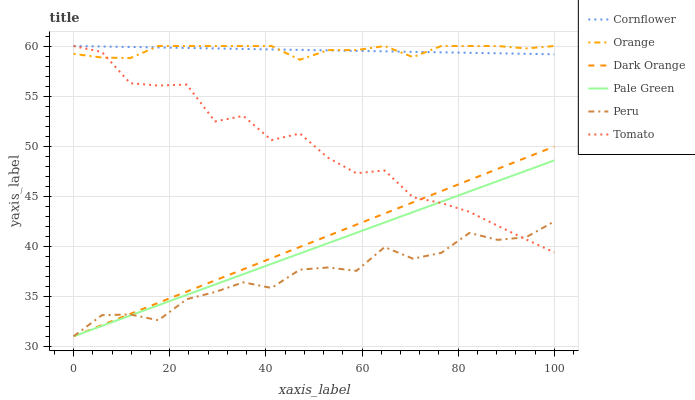Does Peru have the minimum area under the curve?
Answer yes or no. Yes. Does Orange have the maximum area under the curve?
Answer yes or no. Yes. Does Cornflower have the minimum area under the curve?
Answer yes or no. No. Does Cornflower have the maximum area under the curve?
Answer yes or no. No. Is Cornflower the smoothest?
Answer yes or no. Yes. Is Tomato the roughest?
Answer yes or no. Yes. Is Dark Orange the smoothest?
Answer yes or no. No. Is Dark Orange the roughest?
Answer yes or no. No. Does Dark Orange have the lowest value?
Answer yes or no. Yes. Does Cornflower have the lowest value?
Answer yes or no. No. Does Orange have the highest value?
Answer yes or no. Yes. Does Dark Orange have the highest value?
Answer yes or no. No. Is Peru less than Orange?
Answer yes or no. Yes. Is Cornflower greater than Peru?
Answer yes or no. Yes. Does Cornflower intersect Orange?
Answer yes or no. Yes. Is Cornflower less than Orange?
Answer yes or no. No. Is Cornflower greater than Orange?
Answer yes or no. No. Does Peru intersect Orange?
Answer yes or no. No. 